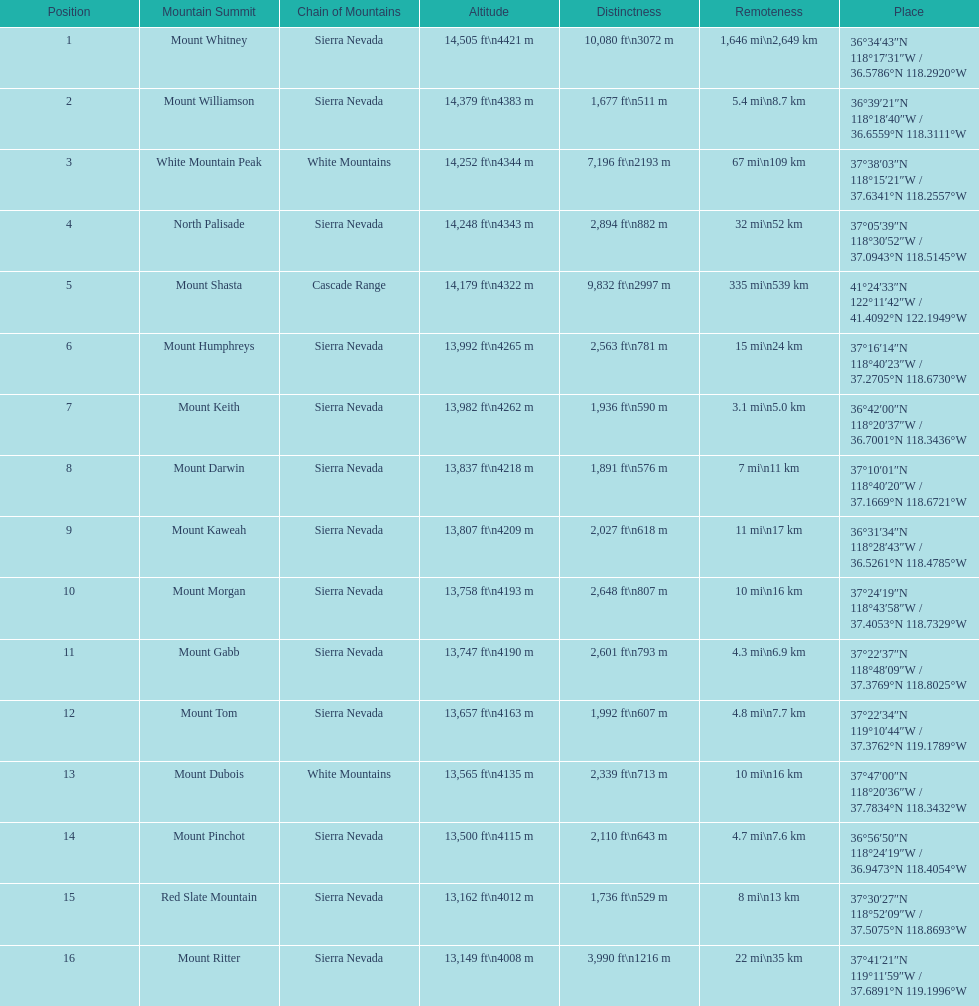Which mountain peak has a prominence more than 10,000 ft? Mount Whitney. 